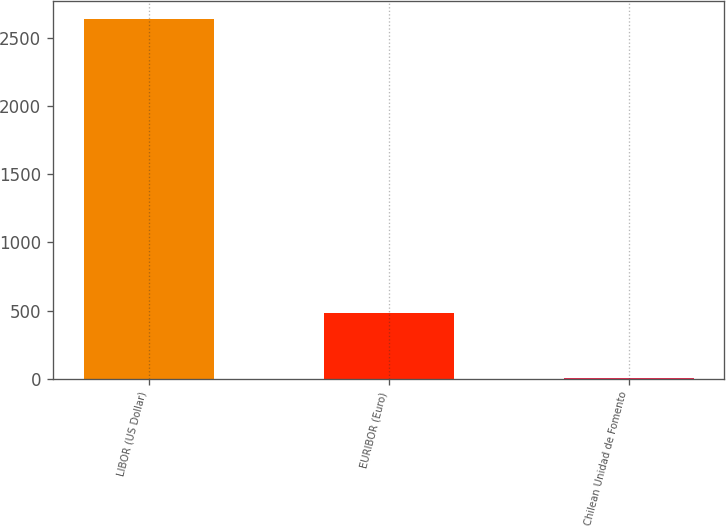Convert chart to OTSL. <chart><loc_0><loc_0><loc_500><loc_500><bar_chart><fcel>LIBOR (US Dollar)<fcel>EURIBOR (Euro)<fcel>Chilean Unidad de Fomento<nl><fcel>2639<fcel>482<fcel>4<nl></chart> 